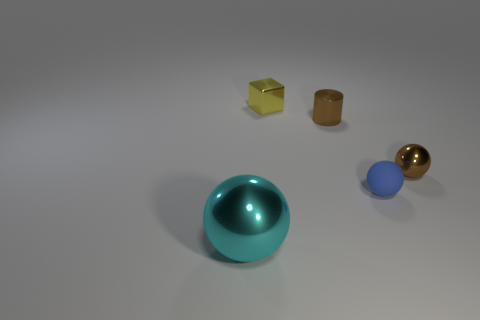Subtract all metal spheres. How many spheres are left? 1 Add 2 blue blocks. How many objects exist? 7 Subtract all cyan spheres. How many spheres are left? 2 Subtract all cylinders. How many objects are left? 4 Subtract all small brown metal spheres. Subtract all tiny brown cylinders. How many objects are left? 3 Add 5 big spheres. How many big spheres are left? 6 Add 1 big matte balls. How many big matte balls exist? 1 Subtract 0 yellow cylinders. How many objects are left? 5 Subtract all yellow spheres. Subtract all gray blocks. How many spheres are left? 3 Subtract all purple cubes. How many gray cylinders are left? 0 